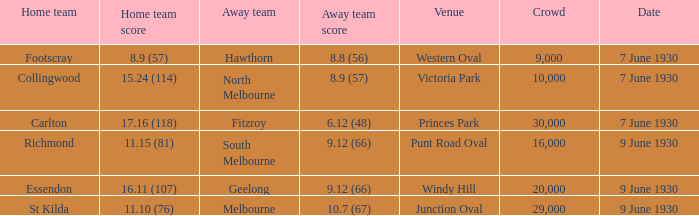What is the mean attendance for hawthorn matches as the away team? 9000.0. 